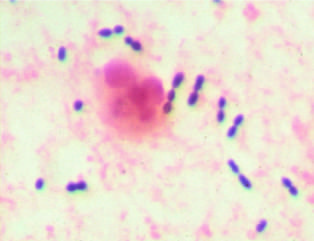s the polyp stain preparation of sputum from a patient with pneumonia?
Answer the question using a single word or phrase. No 